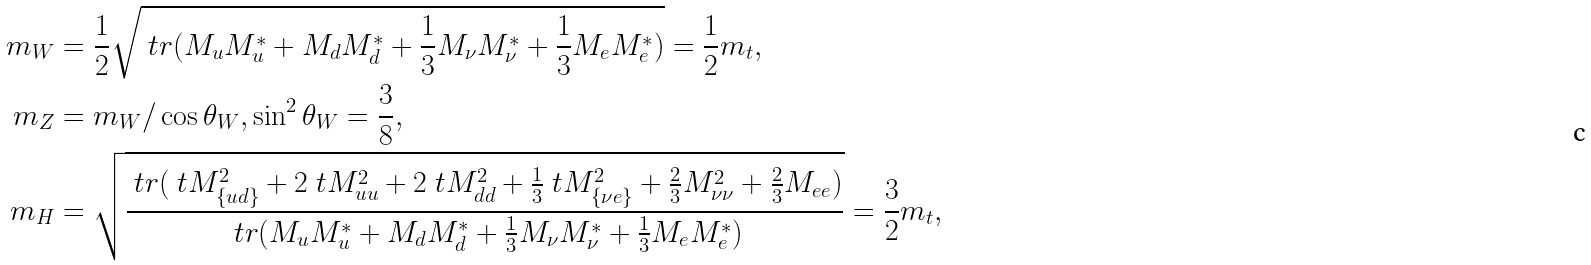<formula> <loc_0><loc_0><loc_500><loc_500>m _ { W } & = \frac { 1 } { 2 } \sqrt { \ t r ( M _ { u } M _ { u } ^ { * } + M _ { d } M _ { d } ^ { * } + \frac { 1 } { 3 } M _ { \nu } M _ { \nu } ^ { * } + \frac { 1 } { 3 } M _ { e } M _ { e } ^ { * } ) } = \frac { 1 } { 2 } m _ { t } , \\ m _ { Z } & = m _ { W } / \cos \theta _ { W } , \sin ^ { 2 } \theta _ { W } = \frac { 3 } { 8 } , \\ m _ { H } & = \sqrt { \frac { \ t r ( \ t { M } _ { \{ u d \} } ^ { 2 } + 2 \ t { M } _ { u u } ^ { 2 } + 2 \ t { M } _ { d d } ^ { 2 } + \frac { 1 } { 3 } \ t { M } _ { \{ \nu e \} } ^ { 2 } + \frac { 2 } { 3 } M _ { \nu \nu } ^ { 2 } + \frac { 2 } { 3 } M _ { e e } ) } { \ t r ( M _ { u } M _ { u } ^ { * } + M _ { d } M _ { d } ^ { * } + \frac { 1 } { 3 } M _ { \nu } M _ { \nu } ^ { * } + \frac { 1 } { 3 } M _ { e } M _ { e } ^ { * } ) } } = \frac { 3 } { 2 } m _ { t } ,</formula> 